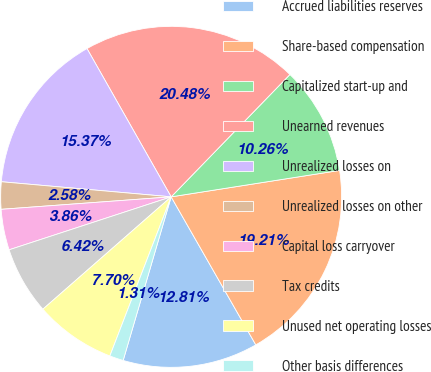Convert chart to OTSL. <chart><loc_0><loc_0><loc_500><loc_500><pie_chart><fcel>Accrued liabilities reserves<fcel>Share-based compensation<fcel>Capitalized start-up and<fcel>Unearned revenues<fcel>Unrealized losses on<fcel>Unrealized losses on other<fcel>Capital loss carryover<fcel>Tax credits<fcel>Unused net operating losses<fcel>Other basis differences<nl><fcel>12.81%<fcel>19.21%<fcel>10.26%<fcel>20.48%<fcel>15.37%<fcel>2.58%<fcel>3.86%<fcel>6.42%<fcel>7.7%<fcel>1.31%<nl></chart> 